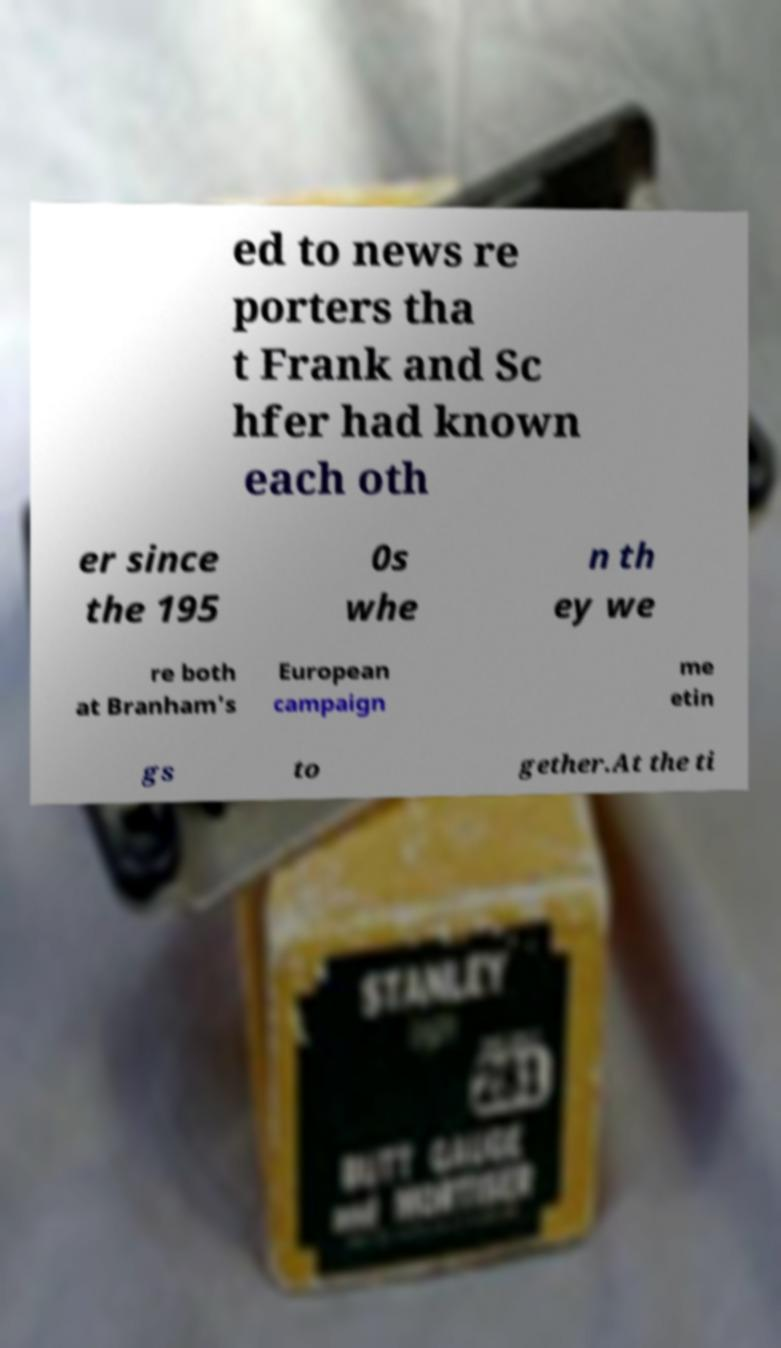For documentation purposes, I need the text within this image transcribed. Could you provide that? ed to news re porters tha t Frank and Sc hfer had known each oth er since the 195 0s whe n th ey we re both at Branham's European campaign me etin gs to gether.At the ti 